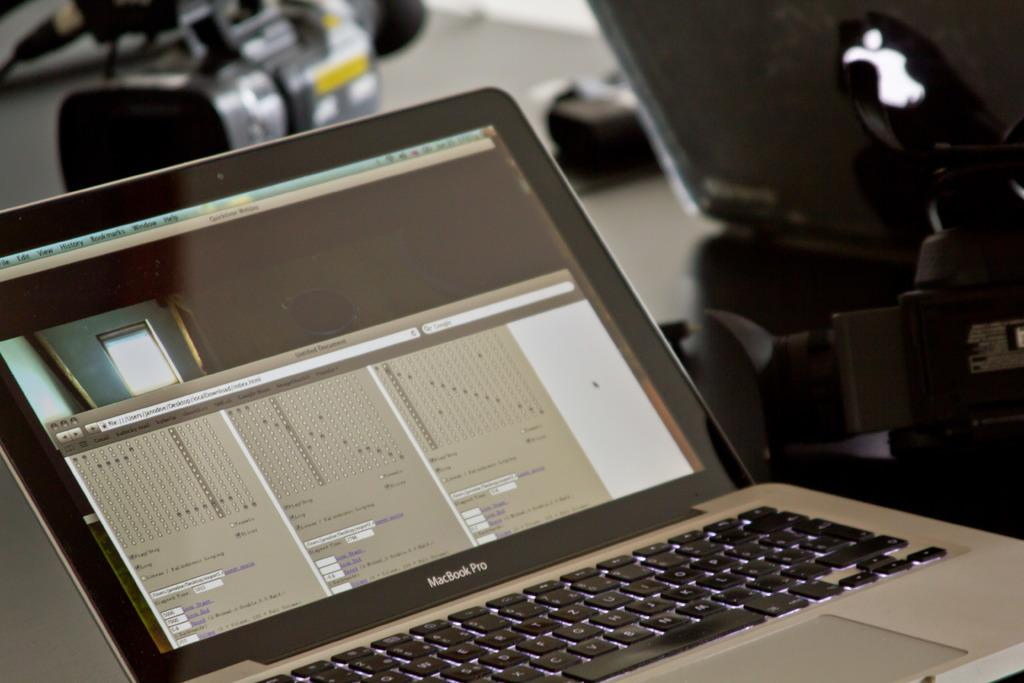What electronic device is present in the image? There is a laptop in the image. What other device is present in the image? There is a camera in the image. What is used to support the camera in the image? There is a camera stand in the image. Where are all these objects placed? All of these objects are placed on a table. What type of humor can be seen in the image? There is no humor present in the image; it features a laptop, a camera, and a camera stand on a table. 